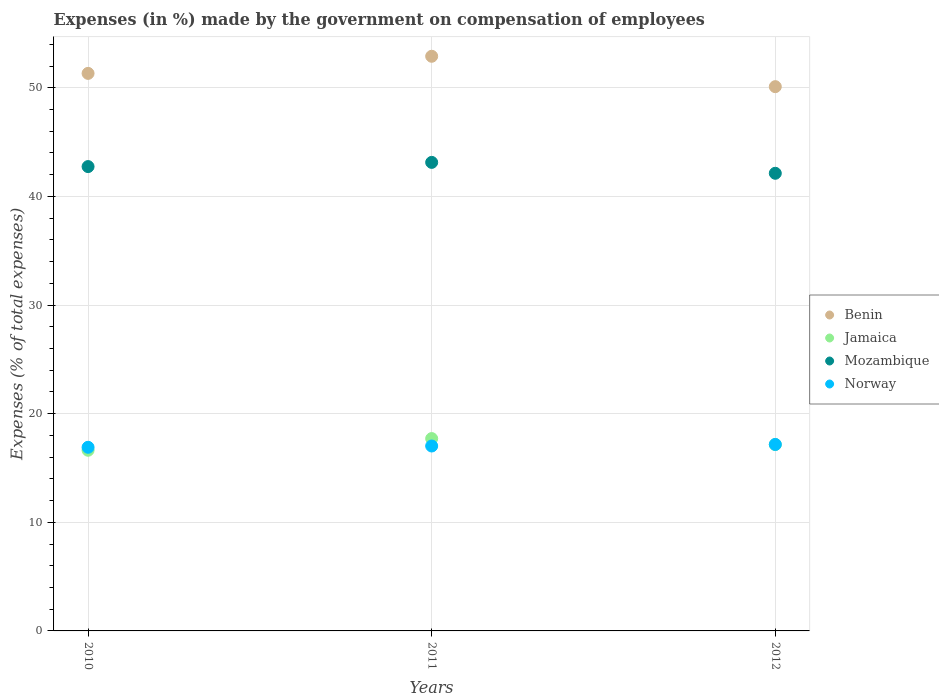What is the percentage of expenses made by the government on compensation of employees in Jamaica in 2011?
Your answer should be compact. 17.71. Across all years, what is the maximum percentage of expenses made by the government on compensation of employees in Norway?
Ensure brevity in your answer.  17.17. Across all years, what is the minimum percentage of expenses made by the government on compensation of employees in Jamaica?
Ensure brevity in your answer.  16.63. What is the total percentage of expenses made by the government on compensation of employees in Norway in the graph?
Your response must be concise. 51.1. What is the difference between the percentage of expenses made by the government on compensation of employees in Norway in 2010 and that in 2011?
Offer a terse response. -0.12. What is the difference between the percentage of expenses made by the government on compensation of employees in Mozambique in 2010 and the percentage of expenses made by the government on compensation of employees in Jamaica in 2012?
Your response must be concise. 25.59. What is the average percentage of expenses made by the government on compensation of employees in Benin per year?
Ensure brevity in your answer.  51.45. In the year 2012, what is the difference between the percentage of expenses made by the government on compensation of employees in Benin and percentage of expenses made by the government on compensation of employees in Norway?
Keep it short and to the point. 32.94. What is the ratio of the percentage of expenses made by the government on compensation of employees in Mozambique in 2010 to that in 2012?
Your answer should be very brief. 1.01. Is the percentage of expenses made by the government on compensation of employees in Benin in 2010 less than that in 2011?
Your response must be concise. Yes. Is the difference between the percentage of expenses made by the government on compensation of employees in Benin in 2010 and 2012 greater than the difference between the percentage of expenses made by the government on compensation of employees in Norway in 2010 and 2012?
Give a very brief answer. Yes. What is the difference between the highest and the second highest percentage of expenses made by the government on compensation of employees in Mozambique?
Provide a succinct answer. 0.39. What is the difference between the highest and the lowest percentage of expenses made by the government on compensation of employees in Mozambique?
Make the answer very short. 1. Is it the case that in every year, the sum of the percentage of expenses made by the government on compensation of employees in Norway and percentage of expenses made by the government on compensation of employees in Jamaica  is greater than the sum of percentage of expenses made by the government on compensation of employees in Mozambique and percentage of expenses made by the government on compensation of employees in Benin?
Offer a terse response. No. Is the percentage of expenses made by the government on compensation of employees in Mozambique strictly greater than the percentage of expenses made by the government on compensation of employees in Jamaica over the years?
Provide a succinct answer. Yes. How many years are there in the graph?
Provide a short and direct response. 3. What is the difference between two consecutive major ticks on the Y-axis?
Your response must be concise. 10. Are the values on the major ticks of Y-axis written in scientific E-notation?
Provide a short and direct response. No. Where does the legend appear in the graph?
Provide a short and direct response. Center right. What is the title of the graph?
Provide a succinct answer. Expenses (in %) made by the government on compensation of employees. Does "Kiribati" appear as one of the legend labels in the graph?
Offer a terse response. No. What is the label or title of the Y-axis?
Your response must be concise. Expenses (% of total expenses). What is the Expenses (% of total expenses) in Benin in 2010?
Ensure brevity in your answer.  51.33. What is the Expenses (% of total expenses) of Jamaica in 2010?
Give a very brief answer. 16.63. What is the Expenses (% of total expenses) of Mozambique in 2010?
Offer a very short reply. 42.75. What is the Expenses (% of total expenses) of Norway in 2010?
Ensure brevity in your answer.  16.91. What is the Expenses (% of total expenses) of Benin in 2011?
Provide a short and direct response. 52.9. What is the Expenses (% of total expenses) in Jamaica in 2011?
Your answer should be very brief. 17.71. What is the Expenses (% of total expenses) in Mozambique in 2011?
Give a very brief answer. 43.13. What is the Expenses (% of total expenses) of Norway in 2011?
Your answer should be compact. 17.02. What is the Expenses (% of total expenses) of Benin in 2012?
Keep it short and to the point. 50.11. What is the Expenses (% of total expenses) of Jamaica in 2012?
Provide a short and direct response. 17.16. What is the Expenses (% of total expenses) of Mozambique in 2012?
Your answer should be compact. 42.13. What is the Expenses (% of total expenses) of Norway in 2012?
Provide a short and direct response. 17.17. Across all years, what is the maximum Expenses (% of total expenses) of Benin?
Make the answer very short. 52.9. Across all years, what is the maximum Expenses (% of total expenses) in Jamaica?
Your response must be concise. 17.71. Across all years, what is the maximum Expenses (% of total expenses) in Mozambique?
Give a very brief answer. 43.13. Across all years, what is the maximum Expenses (% of total expenses) in Norway?
Your response must be concise. 17.17. Across all years, what is the minimum Expenses (% of total expenses) in Benin?
Your answer should be compact. 50.11. Across all years, what is the minimum Expenses (% of total expenses) of Jamaica?
Provide a short and direct response. 16.63. Across all years, what is the minimum Expenses (% of total expenses) of Mozambique?
Your answer should be compact. 42.13. Across all years, what is the minimum Expenses (% of total expenses) of Norway?
Provide a short and direct response. 16.91. What is the total Expenses (% of total expenses) of Benin in the graph?
Your response must be concise. 154.34. What is the total Expenses (% of total expenses) in Jamaica in the graph?
Your answer should be compact. 51.5. What is the total Expenses (% of total expenses) of Mozambique in the graph?
Your answer should be compact. 128.01. What is the total Expenses (% of total expenses) in Norway in the graph?
Keep it short and to the point. 51.1. What is the difference between the Expenses (% of total expenses) of Benin in 2010 and that in 2011?
Provide a short and direct response. -1.58. What is the difference between the Expenses (% of total expenses) of Jamaica in 2010 and that in 2011?
Make the answer very short. -1.07. What is the difference between the Expenses (% of total expenses) of Mozambique in 2010 and that in 2011?
Provide a short and direct response. -0.39. What is the difference between the Expenses (% of total expenses) in Norway in 2010 and that in 2011?
Give a very brief answer. -0.12. What is the difference between the Expenses (% of total expenses) in Benin in 2010 and that in 2012?
Offer a terse response. 1.22. What is the difference between the Expenses (% of total expenses) in Jamaica in 2010 and that in 2012?
Provide a succinct answer. -0.52. What is the difference between the Expenses (% of total expenses) in Mozambique in 2010 and that in 2012?
Your response must be concise. 0.62. What is the difference between the Expenses (% of total expenses) in Norway in 2010 and that in 2012?
Keep it short and to the point. -0.26. What is the difference between the Expenses (% of total expenses) of Benin in 2011 and that in 2012?
Your answer should be compact. 2.8. What is the difference between the Expenses (% of total expenses) in Jamaica in 2011 and that in 2012?
Keep it short and to the point. 0.55. What is the difference between the Expenses (% of total expenses) of Mozambique in 2011 and that in 2012?
Make the answer very short. 1. What is the difference between the Expenses (% of total expenses) of Norway in 2011 and that in 2012?
Offer a terse response. -0.14. What is the difference between the Expenses (% of total expenses) in Benin in 2010 and the Expenses (% of total expenses) in Jamaica in 2011?
Offer a terse response. 33.62. What is the difference between the Expenses (% of total expenses) in Benin in 2010 and the Expenses (% of total expenses) in Mozambique in 2011?
Offer a terse response. 8.19. What is the difference between the Expenses (% of total expenses) of Benin in 2010 and the Expenses (% of total expenses) of Norway in 2011?
Your answer should be very brief. 34.3. What is the difference between the Expenses (% of total expenses) in Jamaica in 2010 and the Expenses (% of total expenses) in Mozambique in 2011?
Your response must be concise. -26.5. What is the difference between the Expenses (% of total expenses) of Jamaica in 2010 and the Expenses (% of total expenses) of Norway in 2011?
Keep it short and to the point. -0.39. What is the difference between the Expenses (% of total expenses) in Mozambique in 2010 and the Expenses (% of total expenses) in Norway in 2011?
Ensure brevity in your answer.  25.72. What is the difference between the Expenses (% of total expenses) in Benin in 2010 and the Expenses (% of total expenses) in Jamaica in 2012?
Provide a succinct answer. 34.17. What is the difference between the Expenses (% of total expenses) of Benin in 2010 and the Expenses (% of total expenses) of Mozambique in 2012?
Offer a very short reply. 9.2. What is the difference between the Expenses (% of total expenses) of Benin in 2010 and the Expenses (% of total expenses) of Norway in 2012?
Your answer should be very brief. 34.16. What is the difference between the Expenses (% of total expenses) of Jamaica in 2010 and the Expenses (% of total expenses) of Mozambique in 2012?
Keep it short and to the point. -25.5. What is the difference between the Expenses (% of total expenses) of Jamaica in 2010 and the Expenses (% of total expenses) of Norway in 2012?
Offer a very short reply. -0.53. What is the difference between the Expenses (% of total expenses) of Mozambique in 2010 and the Expenses (% of total expenses) of Norway in 2012?
Your answer should be very brief. 25.58. What is the difference between the Expenses (% of total expenses) of Benin in 2011 and the Expenses (% of total expenses) of Jamaica in 2012?
Ensure brevity in your answer.  35.75. What is the difference between the Expenses (% of total expenses) of Benin in 2011 and the Expenses (% of total expenses) of Mozambique in 2012?
Your answer should be compact. 10.77. What is the difference between the Expenses (% of total expenses) of Benin in 2011 and the Expenses (% of total expenses) of Norway in 2012?
Provide a succinct answer. 35.74. What is the difference between the Expenses (% of total expenses) in Jamaica in 2011 and the Expenses (% of total expenses) in Mozambique in 2012?
Ensure brevity in your answer.  -24.42. What is the difference between the Expenses (% of total expenses) in Jamaica in 2011 and the Expenses (% of total expenses) in Norway in 2012?
Your answer should be compact. 0.54. What is the difference between the Expenses (% of total expenses) of Mozambique in 2011 and the Expenses (% of total expenses) of Norway in 2012?
Make the answer very short. 25.97. What is the average Expenses (% of total expenses) in Benin per year?
Ensure brevity in your answer.  51.45. What is the average Expenses (% of total expenses) in Jamaica per year?
Make the answer very short. 17.17. What is the average Expenses (% of total expenses) in Mozambique per year?
Provide a short and direct response. 42.67. What is the average Expenses (% of total expenses) in Norway per year?
Ensure brevity in your answer.  17.03. In the year 2010, what is the difference between the Expenses (% of total expenses) in Benin and Expenses (% of total expenses) in Jamaica?
Your answer should be compact. 34.69. In the year 2010, what is the difference between the Expenses (% of total expenses) in Benin and Expenses (% of total expenses) in Mozambique?
Offer a terse response. 8.58. In the year 2010, what is the difference between the Expenses (% of total expenses) of Benin and Expenses (% of total expenses) of Norway?
Offer a terse response. 34.42. In the year 2010, what is the difference between the Expenses (% of total expenses) in Jamaica and Expenses (% of total expenses) in Mozambique?
Your answer should be very brief. -26.11. In the year 2010, what is the difference between the Expenses (% of total expenses) of Jamaica and Expenses (% of total expenses) of Norway?
Offer a very short reply. -0.27. In the year 2010, what is the difference between the Expenses (% of total expenses) in Mozambique and Expenses (% of total expenses) in Norway?
Provide a succinct answer. 25.84. In the year 2011, what is the difference between the Expenses (% of total expenses) in Benin and Expenses (% of total expenses) in Jamaica?
Keep it short and to the point. 35.2. In the year 2011, what is the difference between the Expenses (% of total expenses) in Benin and Expenses (% of total expenses) in Mozambique?
Provide a succinct answer. 9.77. In the year 2011, what is the difference between the Expenses (% of total expenses) of Benin and Expenses (% of total expenses) of Norway?
Offer a very short reply. 35.88. In the year 2011, what is the difference between the Expenses (% of total expenses) in Jamaica and Expenses (% of total expenses) in Mozambique?
Provide a short and direct response. -25.43. In the year 2011, what is the difference between the Expenses (% of total expenses) in Jamaica and Expenses (% of total expenses) in Norway?
Your answer should be compact. 0.68. In the year 2011, what is the difference between the Expenses (% of total expenses) in Mozambique and Expenses (% of total expenses) in Norway?
Your answer should be very brief. 26.11. In the year 2012, what is the difference between the Expenses (% of total expenses) of Benin and Expenses (% of total expenses) of Jamaica?
Your answer should be compact. 32.95. In the year 2012, what is the difference between the Expenses (% of total expenses) of Benin and Expenses (% of total expenses) of Mozambique?
Your response must be concise. 7.97. In the year 2012, what is the difference between the Expenses (% of total expenses) in Benin and Expenses (% of total expenses) in Norway?
Give a very brief answer. 32.94. In the year 2012, what is the difference between the Expenses (% of total expenses) in Jamaica and Expenses (% of total expenses) in Mozambique?
Your response must be concise. -24.97. In the year 2012, what is the difference between the Expenses (% of total expenses) in Jamaica and Expenses (% of total expenses) in Norway?
Provide a succinct answer. -0.01. In the year 2012, what is the difference between the Expenses (% of total expenses) of Mozambique and Expenses (% of total expenses) of Norway?
Make the answer very short. 24.96. What is the ratio of the Expenses (% of total expenses) in Benin in 2010 to that in 2011?
Give a very brief answer. 0.97. What is the ratio of the Expenses (% of total expenses) of Jamaica in 2010 to that in 2011?
Your response must be concise. 0.94. What is the ratio of the Expenses (% of total expenses) in Mozambique in 2010 to that in 2011?
Provide a short and direct response. 0.99. What is the ratio of the Expenses (% of total expenses) in Norway in 2010 to that in 2011?
Ensure brevity in your answer.  0.99. What is the ratio of the Expenses (% of total expenses) in Benin in 2010 to that in 2012?
Keep it short and to the point. 1.02. What is the ratio of the Expenses (% of total expenses) of Jamaica in 2010 to that in 2012?
Offer a very short reply. 0.97. What is the ratio of the Expenses (% of total expenses) in Mozambique in 2010 to that in 2012?
Give a very brief answer. 1.01. What is the ratio of the Expenses (% of total expenses) in Norway in 2010 to that in 2012?
Provide a succinct answer. 0.98. What is the ratio of the Expenses (% of total expenses) of Benin in 2011 to that in 2012?
Provide a short and direct response. 1.06. What is the ratio of the Expenses (% of total expenses) of Jamaica in 2011 to that in 2012?
Your answer should be very brief. 1.03. What is the ratio of the Expenses (% of total expenses) in Mozambique in 2011 to that in 2012?
Ensure brevity in your answer.  1.02. What is the ratio of the Expenses (% of total expenses) in Norway in 2011 to that in 2012?
Provide a short and direct response. 0.99. What is the difference between the highest and the second highest Expenses (% of total expenses) in Benin?
Offer a very short reply. 1.58. What is the difference between the highest and the second highest Expenses (% of total expenses) in Jamaica?
Provide a succinct answer. 0.55. What is the difference between the highest and the second highest Expenses (% of total expenses) in Mozambique?
Keep it short and to the point. 0.39. What is the difference between the highest and the second highest Expenses (% of total expenses) in Norway?
Offer a very short reply. 0.14. What is the difference between the highest and the lowest Expenses (% of total expenses) in Benin?
Your answer should be very brief. 2.8. What is the difference between the highest and the lowest Expenses (% of total expenses) in Jamaica?
Keep it short and to the point. 1.07. What is the difference between the highest and the lowest Expenses (% of total expenses) in Norway?
Ensure brevity in your answer.  0.26. 